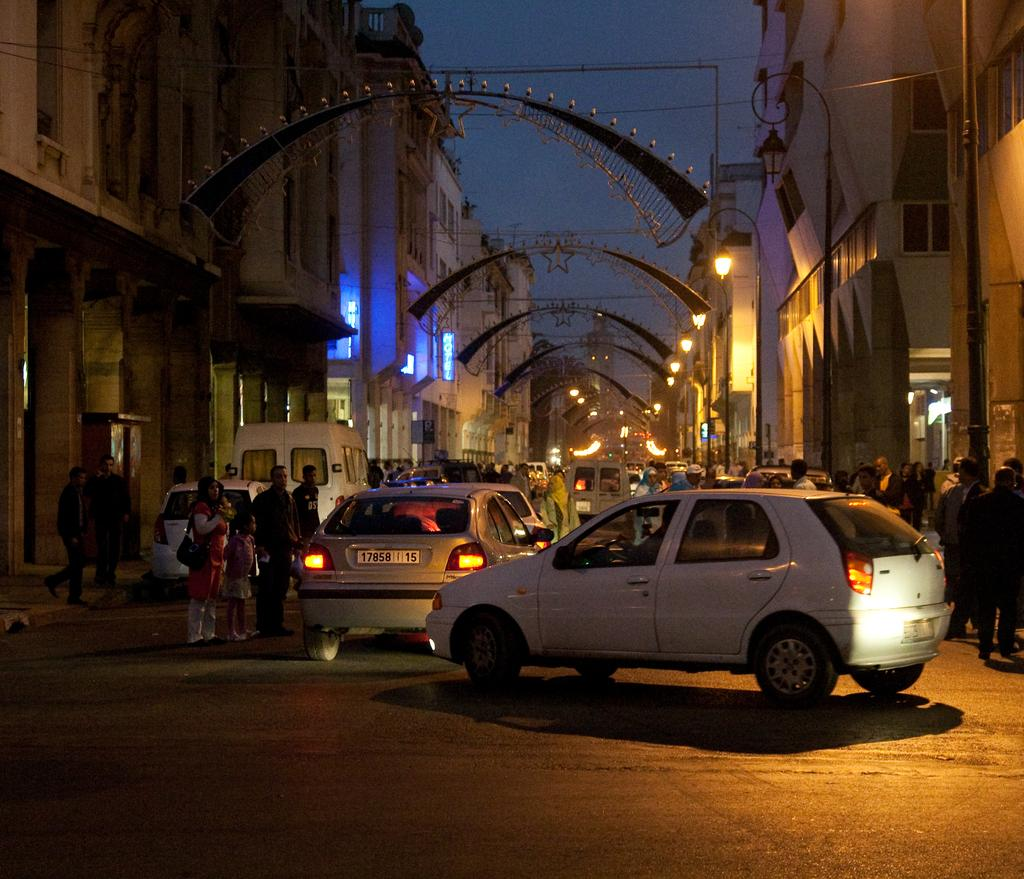What type of vehicles can be seen in the image? There are cars in the image. What are the people on the road doing? There are people standing on the road in the image. What structures are present on both sides of the road? There are buildings on both sides of the road in the image. What type of lighting is present along the road? There are street lights in the image. What can be seen in the background of the image? The sky is visible in the background of the image. What type of wool is being used to grade the road in the image? There is no wool or grading activity present in the image. What kind of watch can be seen on the wrist of the person standing on the road? There is no watch visible on any person's wrist in the image. 